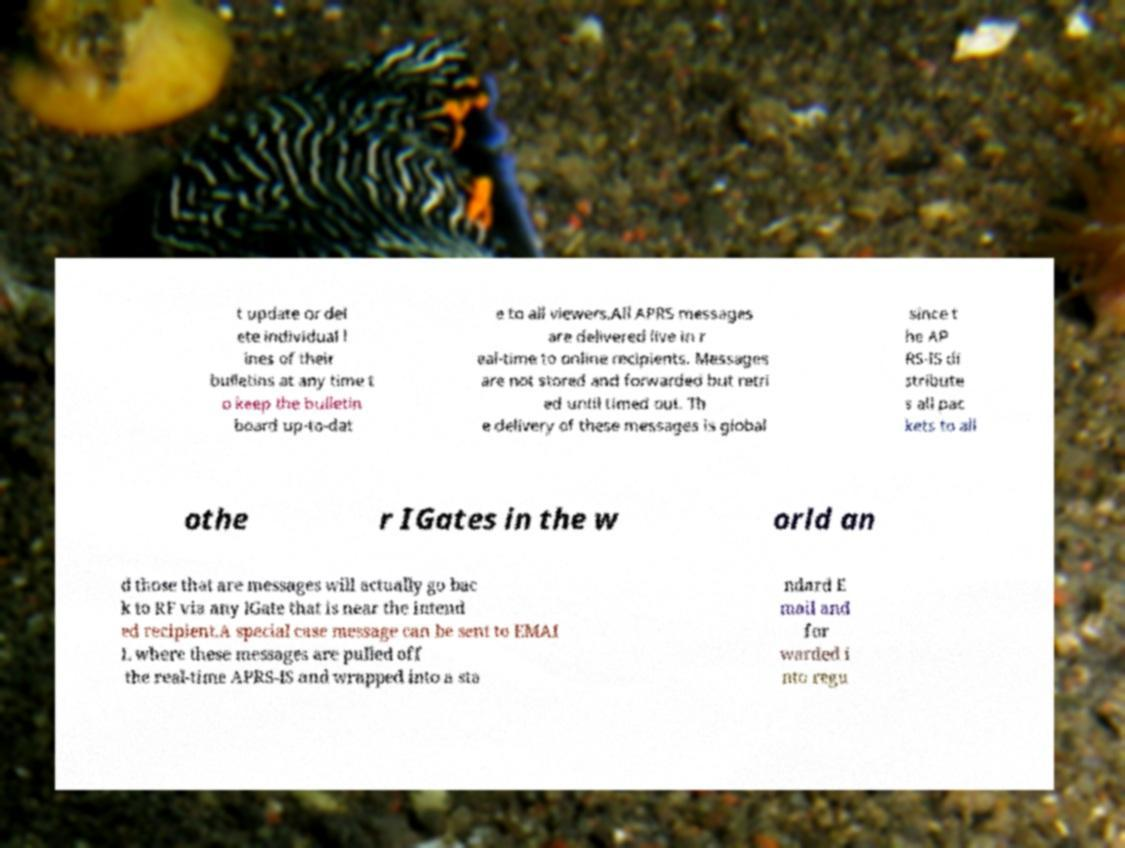What messages or text are displayed in this image? I need them in a readable, typed format. t update or del ete individual l ines of their bulletins at any time t o keep the bulletin board up-to-dat e to all viewers.All APRS messages are delivered live in r eal-time to online recipients. Messages are not stored and forwarded but retri ed until timed out. Th e delivery of these messages is global since t he AP RS-IS di stribute s all pac kets to all othe r IGates in the w orld an d those that are messages will actually go bac k to RF via any IGate that is near the intend ed recipient.A special case message can be sent to EMAI L where these messages are pulled off the real-time APRS-IS and wrapped into a sta ndard E mail and for warded i nto regu 